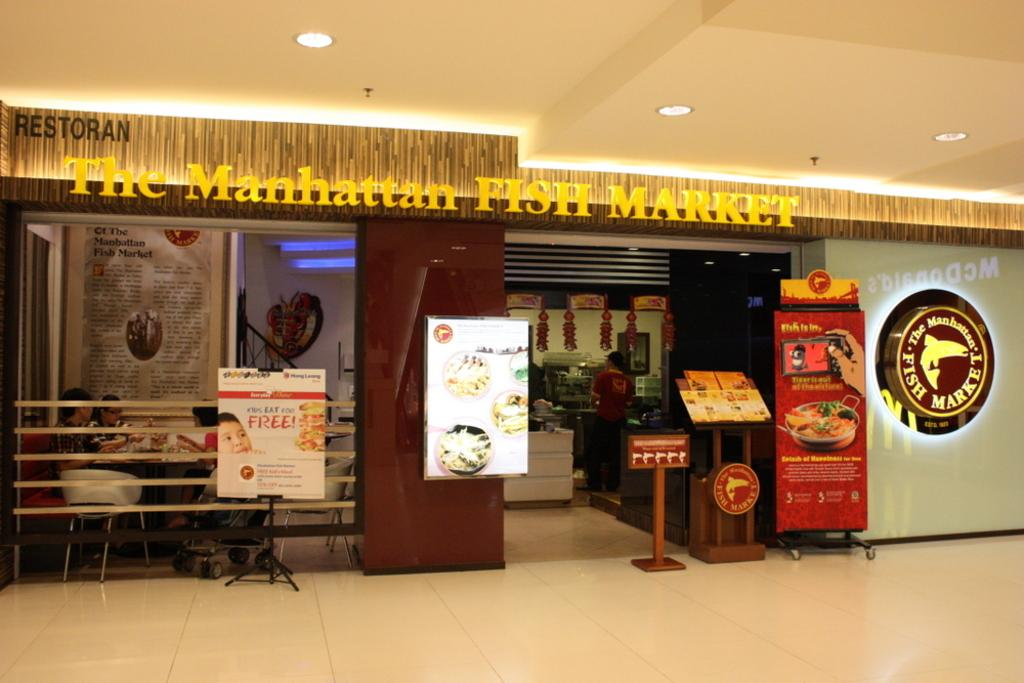Provide a one-sentence caption for the provided image. The manhattan fish market restaurant with people sitting inside. 